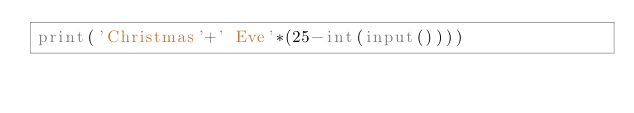Convert code to text. <code><loc_0><loc_0><loc_500><loc_500><_Python_>print('Christmas'+' Eve'*(25-int(input())))</code> 